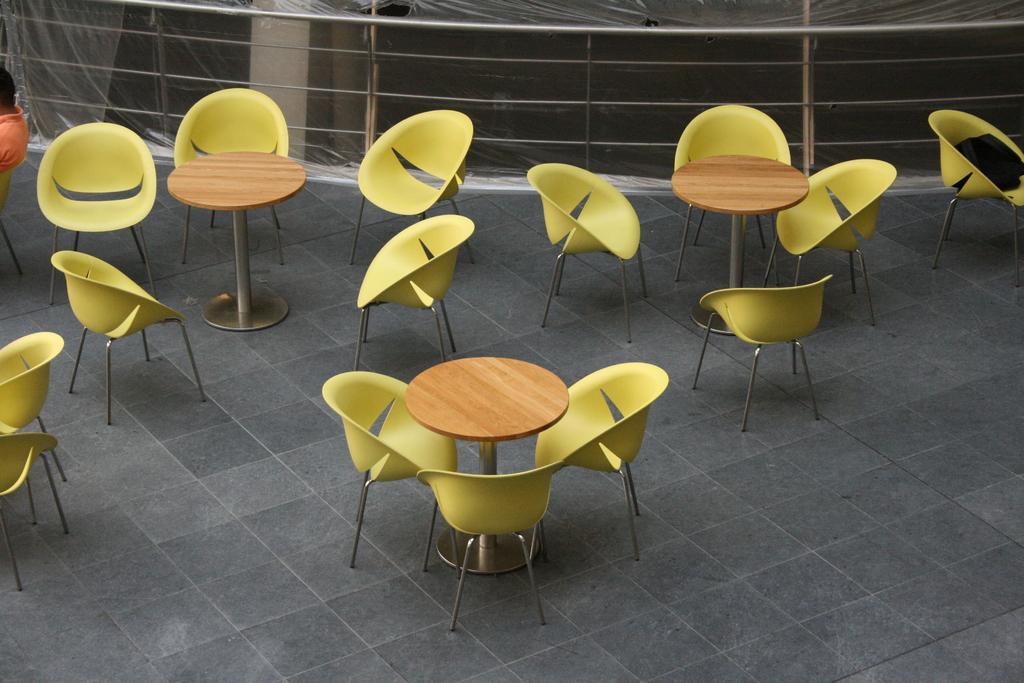How would you summarize this image in a sentence or two? in this picture, we see the empty chairs and the round shaped tables. These chairs are in yellow color. In the background, we see the railing and a pillar. 